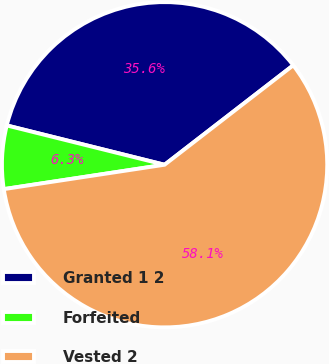Convert chart. <chart><loc_0><loc_0><loc_500><loc_500><pie_chart><fcel>Granted 1 2<fcel>Forfeited<fcel>Vested 2<nl><fcel>35.64%<fcel>6.28%<fcel>58.07%<nl></chart> 